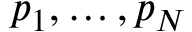Convert formula to latex. <formula><loc_0><loc_0><loc_500><loc_500>p _ { 1 } , \dots , p _ { N }</formula> 